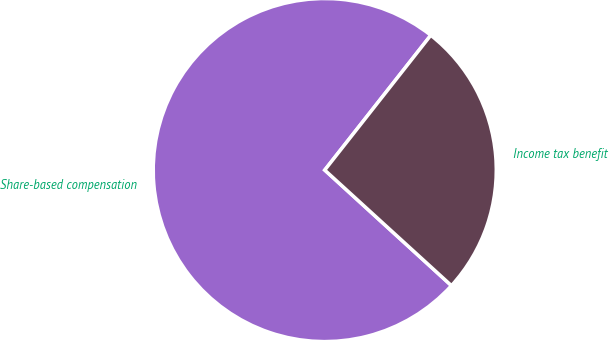<chart> <loc_0><loc_0><loc_500><loc_500><pie_chart><fcel>Share-based compensation<fcel>Income tax benefit<nl><fcel>73.84%<fcel>26.16%<nl></chart> 